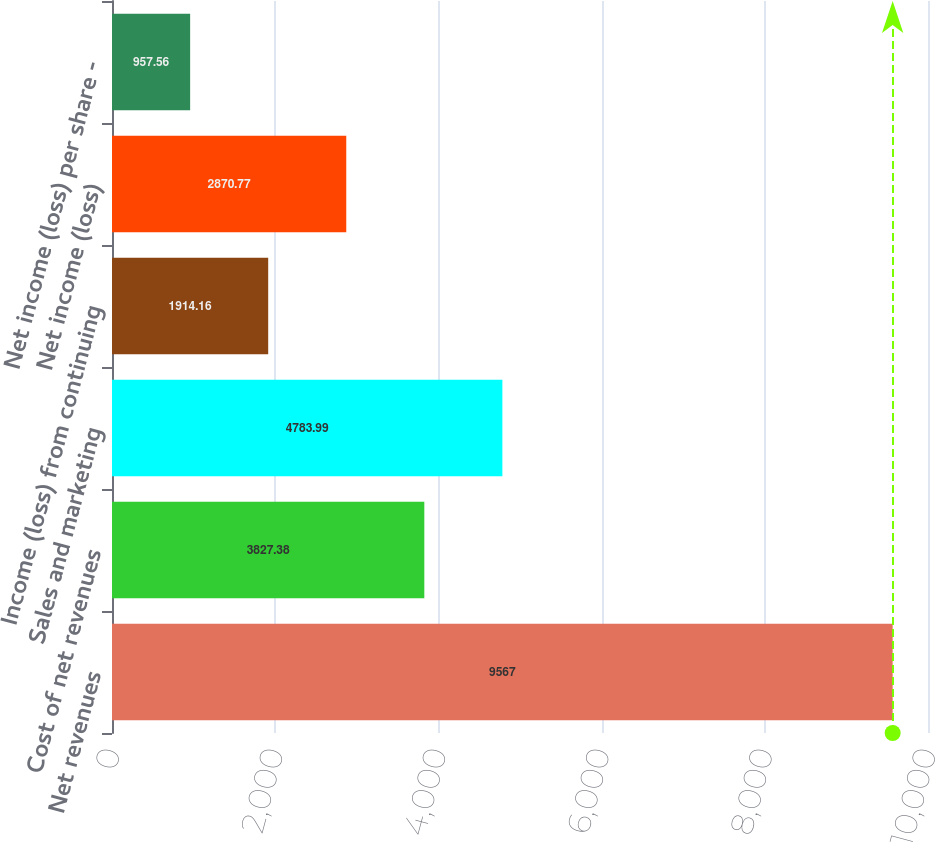Convert chart to OTSL. <chart><loc_0><loc_0><loc_500><loc_500><bar_chart><fcel>Net revenues<fcel>Cost of net revenues<fcel>Sales and marketing<fcel>Income (loss) from continuing<fcel>Net income (loss)<fcel>Net income (loss) per share -<nl><fcel>9567<fcel>3827.38<fcel>4783.99<fcel>1914.16<fcel>2870.77<fcel>957.56<nl></chart> 